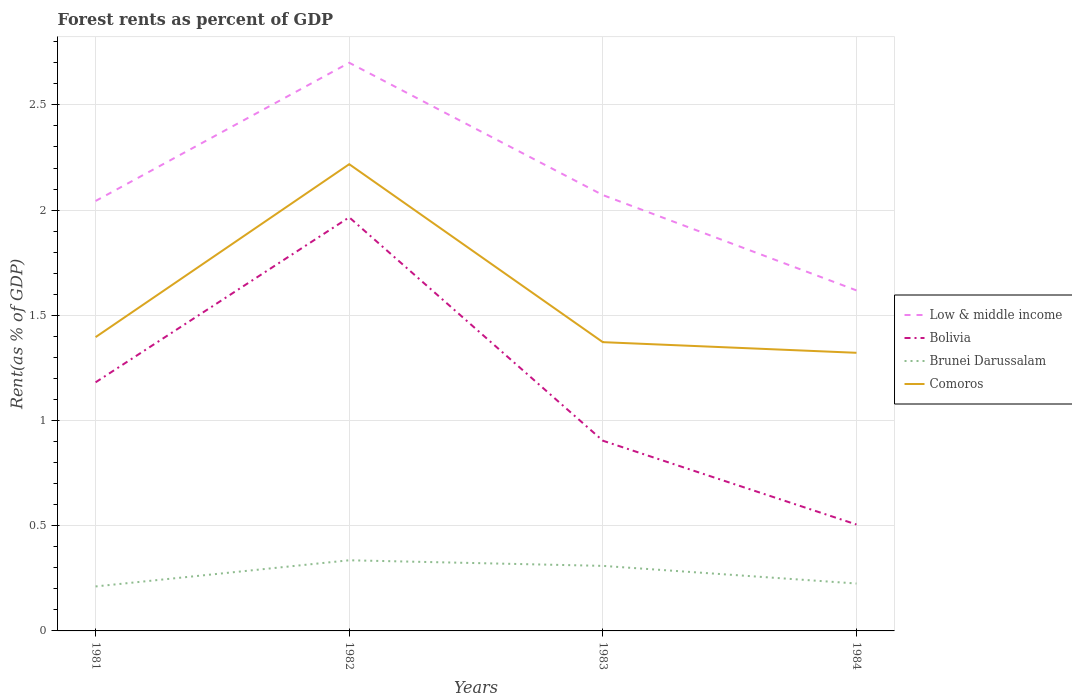Across all years, what is the maximum forest rent in Low & middle income?
Offer a very short reply. 1.62. What is the total forest rent in Low & middle income in the graph?
Make the answer very short. -0.66. What is the difference between the highest and the second highest forest rent in Bolivia?
Ensure brevity in your answer.  1.46. Is the forest rent in Bolivia strictly greater than the forest rent in Low & middle income over the years?
Give a very brief answer. Yes. Are the values on the major ticks of Y-axis written in scientific E-notation?
Offer a terse response. No. Where does the legend appear in the graph?
Keep it short and to the point. Center right. What is the title of the graph?
Offer a very short reply. Forest rents as percent of GDP. What is the label or title of the Y-axis?
Your answer should be very brief. Rent(as % of GDP). What is the Rent(as % of GDP) in Low & middle income in 1981?
Make the answer very short. 2.04. What is the Rent(as % of GDP) of Bolivia in 1981?
Your answer should be compact. 1.18. What is the Rent(as % of GDP) of Brunei Darussalam in 1981?
Your response must be concise. 0.21. What is the Rent(as % of GDP) of Comoros in 1981?
Keep it short and to the point. 1.4. What is the Rent(as % of GDP) of Low & middle income in 1982?
Ensure brevity in your answer.  2.7. What is the Rent(as % of GDP) of Bolivia in 1982?
Your answer should be very brief. 1.97. What is the Rent(as % of GDP) of Brunei Darussalam in 1982?
Give a very brief answer. 0.34. What is the Rent(as % of GDP) in Comoros in 1982?
Your answer should be compact. 2.22. What is the Rent(as % of GDP) of Low & middle income in 1983?
Your answer should be compact. 2.07. What is the Rent(as % of GDP) of Bolivia in 1983?
Provide a succinct answer. 0.9. What is the Rent(as % of GDP) in Brunei Darussalam in 1983?
Keep it short and to the point. 0.31. What is the Rent(as % of GDP) of Comoros in 1983?
Provide a short and direct response. 1.37. What is the Rent(as % of GDP) in Low & middle income in 1984?
Offer a terse response. 1.62. What is the Rent(as % of GDP) in Bolivia in 1984?
Your answer should be very brief. 0.51. What is the Rent(as % of GDP) of Brunei Darussalam in 1984?
Ensure brevity in your answer.  0.23. What is the Rent(as % of GDP) in Comoros in 1984?
Ensure brevity in your answer.  1.32. Across all years, what is the maximum Rent(as % of GDP) in Low & middle income?
Make the answer very short. 2.7. Across all years, what is the maximum Rent(as % of GDP) in Bolivia?
Your answer should be compact. 1.97. Across all years, what is the maximum Rent(as % of GDP) of Brunei Darussalam?
Make the answer very short. 0.34. Across all years, what is the maximum Rent(as % of GDP) of Comoros?
Offer a very short reply. 2.22. Across all years, what is the minimum Rent(as % of GDP) of Low & middle income?
Keep it short and to the point. 1.62. Across all years, what is the minimum Rent(as % of GDP) in Bolivia?
Provide a succinct answer. 0.51. Across all years, what is the minimum Rent(as % of GDP) of Brunei Darussalam?
Provide a short and direct response. 0.21. Across all years, what is the minimum Rent(as % of GDP) of Comoros?
Your answer should be compact. 1.32. What is the total Rent(as % of GDP) in Low & middle income in the graph?
Give a very brief answer. 8.43. What is the total Rent(as % of GDP) in Bolivia in the graph?
Your answer should be very brief. 4.56. What is the total Rent(as % of GDP) in Brunei Darussalam in the graph?
Ensure brevity in your answer.  1.08. What is the total Rent(as % of GDP) of Comoros in the graph?
Give a very brief answer. 6.31. What is the difference between the Rent(as % of GDP) in Low & middle income in 1981 and that in 1982?
Your answer should be very brief. -0.66. What is the difference between the Rent(as % of GDP) of Bolivia in 1981 and that in 1982?
Offer a terse response. -0.78. What is the difference between the Rent(as % of GDP) of Brunei Darussalam in 1981 and that in 1982?
Keep it short and to the point. -0.12. What is the difference between the Rent(as % of GDP) in Comoros in 1981 and that in 1982?
Keep it short and to the point. -0.82. What is the difference between the Rent(as % of GDP) in Low & middle income in 1981 and that in 1983?
Your answer should be very brief. -0.03. What is the difference between the Rent(as % of GDP) of Bolivia in 1981 and that in 1983?
Your answer should be compact. 0.28. What is the difference between the Rent(as % of GDP) in Brunei Darussalam in 1981 and that in 1983?
Provide a succinct answer. -0.1. What is the difference between the Rent(as % of GDP) in Comoros in 1981 and that in 1983?
Make the answer very short. 0.02. What is the difference between the Rent(as % of GDP) of Low & middle income in 1981 and that in 1984?
Offer a very short reply. 0.42. What is the difference between the Rent(as % of GDP) in Bolivia in 1981 and that in 1984?
Provide a succinct answer. 0.68. What is the difference between the Rent(as % of GDP) in Brunei Darussalam in 1981 and that in 1984?
Provide a short and direct response. -0.01. What is the difference between the Rent(as % of GDP) in Comoros in 1981 and that in 1984?
Your answer should be compact. 0.07. What is the difference between the Rent(as % of GDP) in Low & middle income in 1982 and that in 1983?
Ensure brevity in your answer.  0.63. What is the difference between the Rent(as % of GDP) in Bolivia in 1982 and that in 1983?
Provide a succinct answer. 1.06. What is the difference between the Rent(as % of GDP) in Brunei Darussalam in 1982 and that in 1983?
Your response must be concise. 0.03. What is the difference between the Rent(as % of GDP) of Comoros in 1982 and that in 1983?
Keep it short and to the point. 0.85. What is the difference between the Rent(as % of GDP) in Low & middle income in 1982 and that in 1984?
Your answer should be compact. 1.08. What is the difference between the Rent(as % of GDP) of Bolivia in 1982 and that in 1984?
Your response must be concise. 1.46. What is the difference between the Rent(as % of GDP) in Brunei Darussalam in 1982 and that in 1984?
Provide a short and direct response. 0.11. What is the difference between the Rent(as % of GDP) of Comoros in 1982 and that in 1984?
Offer a terse response. 0.9. What is the difference between the Rent(as % of GDP) of Low & middle income in 1983 and that in 1984?
Your answer should be very brief. 0.45. What is the difference between the Rent(as % of GDP) in Bolivia in 1983 and that in 1984?
Offer a very short reply. 0.4. What is the difference between the Rent(as % of GDP) of Brunei Darussalam in 1983 and that in 1984?
Your answer should be compact. 0.08. What is the difference between the Rent(as % of GDP) of Comoros in 1983 and that in 1984?
Provide a short and direct response. 0.05. What is the difference between the Rent(as % of GDP) in Low & middle income in 1981 and the Rent(as % of GDP) in Bolivia in 1982?
Keep it short and to the point. 0.08. What is the difference between the Rent(as % of GDP) in Low & middle income in 1981 and the Rent(as % of GDP) in Brunei Darussalam in 1982?
Give a very brief answer. 1.71. What is the difference between the Rent(as % of GDP) of Low & middle income in 1981 and the Rent(as % of GDP) of Comoros in 1982?
Offer a terse response. -0.17. What is the difference between the Rent(as % of GDP) of Bolivia in 1981 and the Rent(as % of GDP) of Brunei Darussalam in 1982?
Give a very brief answer. 0.85. What is the difference between the Rent(as % of GDP) in Bolivia in 1981 and the Rent(as % of GDP) in Comoros in 1982?
Your response must be concise. -1.04. What is the difference between the Rent(as % of GDP) in Brunei Darussalam in 1981 and the Rent(as % of GDP) in Comoros in 1982?
Provide a succinct answer. -2.01. What is the difference between the Rent(as % of GDP) in Low & middle income in 1981 and the Rent(as % of GDP) in Bolivia in 1983?
Ensure brevity in your answer.  1.14. What is the difference between the Rent(as % of GDP) in Low & middle income in 1981 and the Rent(as % of GDP) in Brunei Darussalam in 1983?
Give a very brief answer. 1.73. What is the difference between the Rent(as % of GDP) in Low & middle income in 1981 and the Rent(as % of GDP) in Comoros in 1983?
Ensure brevity in your answer.  0.67. What is the difference between the Rent(as % of GDP) in Bolivia in 1981 and the Rent(as % of GDP) in Brunei Darussalam in 1983?
Provide a short and direct response. 0.87. What is the difference between the Rent(as % of GDP) in Bolivia in 1981 and the Rent(as % of GDP) in Comoros in 1983?
Make the answer very short. -0.19. What is the difference between the Rent(as % of GDP) of Brunei Darussalam in 1981 and the Rent(as % of GDP) of Comoros in 1983?
Ensure brevity in your answer.  -1.16. What is the difference between the Rent(as % of GDP) of Low & middle income in 1981 and the Rent(as % of GDP) of Bolivia in 1984?
Offer a terse response. 1.54. What is the difference between the Rent(as % of GDP) in Low & middle income in 1981 and the Rent(as % of GDP) in Brunei Darussalam in 1984?
Offer a very short reply. 1.82. What is the difference between the Rent(as % of GDP) in Low & middle income in 1981 and the Rent(as % of GDP) in Comoros in 1984?
Offer a very short reply. 0.72. What is the difference between the Rent(as % of GDP) of Bolivia in 1981 and the Rent(as % of GDP) of Brunei Darussalam in 1984?
Your answer should be compact. 0.96. What is the difference between the Rent(as % of GDP) in Bolivia in 1981 and the Rent(as % of GDP) in Comoros in 1984?
Make the answer very short. -0.14. What is the difference between the Rent(as % of GDP) in Brunei Darussalam in 1981 and the Rent(as % of GDP) in Comoros in 1984?
Your response must be concise. -1.11. What is the difference between the Rent(as % of GDP) of Low & middle income in 1982 and the Rent(as % of GDP) of Bolivia in 1983?
Keep it short and to the point. 1.8. What is the difference between the Rent(as % of GDP) in Low & middle income in 1982 and the Rent(as % of GDP) in Brunei Darussalam in 1983?
Offer a very short reply. 2.39. What is the difference between the Rent(as % of GDP) of Low & middle income in 1982 and the Rent(as % of GDP) of Comoros in 1983?
Your response must be concise. 1.33. What is the difference between the Rent(as % of GDP) of Bolivia in 1982 and the Rent(as % of GDP) of Brunei Darussalam in 1983?
Keep it short and to the point. 1.66. What is the difference between the Rent(as % of GDP) in Bolivia in 1982 and the Rent(as % of GDP) in Comoros in 1983?
Provide a short and direct response. 0.59. What is the difference between the Rent(as % of GDP) of Brunei Darussalam in 1982 and the Rent(as % of GDP) of Comoros in 1983?
Give a very brief answer. -1.04. What is the difference between the Rent(as % of GDP) in Low & middle income in 1982 and the Rent(as % of GDP) in Bolivia in 1984?
Your answer should be compact. 2.19. What is the difference between the Rent(as % of GDP) of Low & middle income in 1982 and the Rent(as % of GDP) of Brunei Darussalam in 1984?
Offer a terse response. 2.48. What is the difference between the Rent(as % of GDP) in Low & middle income in 1982 and the Rent(as % of GDP) in Comoros in 1984?
Provide a short and direct response. 1.38. What is the difference between the Rent(as % of GDP) of Bolivia in 1982 and the Rent(as % of GDP) of Brunei Darussalam in 1984?
Your answer should be compact. 1.74. What is the difference between the Rent(as % of GDP) in Bolivia in 1982 and the Rent(as % of GDP) in Comoros in 1984?
Provide a short and direct response. 0.64. What is the difference between the Rent(as % of GDP) in Brunei Darussalam in 1982 and the Rent(as % of GDP) in Comoros in 1984?
Provide a short and direct response. -0.99. What is the difference between the Rent(as % of GDP) in Low & middle income in 1983 and the Rent(as % of GDP) in Bolivia in 1984?
Your answer should be compact. 1.57. What is the difference between the Rent(as % of GDP) of Low & middle income in 1983 and the Rent(as % of GDP) of Brunei Darussalam in 1984?
Provide a succinct answer. 1.85. What is the difference between the Rent(as % of GDP) of Low & middle income in 1983 and the Rent(as % of GDP) of Comoros in 1984?
Give a very brief answer. 0.75. What is the difference between the Rent(as % of GDP) of Bolivia in 1983 and the Rent(as % of GDP) of Brunei Darussalam in 1984?
Ensure brevity in your answer.  0.68. What is the difference between the Rent(as % of GDP) of Bolivia in 1983 and the Rent(as % of GDP) of Comoros in 1984?
Ensure brevity in your answer.  -0.42. What is the difference between the Rent(as % of GDP) in Brunei Darussalam in 1983 and the Rent(as % of GDP) in Comoros in 1984?
Keep it short and to the point. -1.01. What is the average Rent(as % of GDP) in Low & middle income per year?
Your answer should be compact. 2.11. What is the average Rent(as % of GDP) in Bolivia per year?
Your answer should be compact. 1.14. What is the average Rent(as % of GDP) in Brunei Darussalam per year?
Make the answer very short. 0.27. What is the average Rent(as % of GDP) in Comoros per year?
Provide a succinct answer. 1.58. In the year 1981, what is the difference between the Rent(as % of GDP) in Low & middle income and Rent(as % of GDP) in Bolivia?
Your response must be concise. 0.86. In the year 1981, what is the difference between the Rent(as % of GDP) in Low & middle income and Rent(as % of GDP) in Brunei Darussalam?
Keep it short and to the point. 1.83. In the year 1981, what is the difference between the Rent(as % of GDP) of Low & middle income and Rent(as % of GDP) of Comoros?
Keep it short and to the point. 0.65. In the year 1981, what is the difference between the Rent(as % of GDP) in Bolivia and Rent(as % of GDP) in Brunei Darussalam?
Your answer should be compact. 0.97. In the year 1981, what is the difference between the Rent(as % of GDP) in Bolivia and Rent(as % of GDP) in Comoros?
Make the answer very short. -0.21. In the year 1981, what is the difference between the Rent(as % of GDP) in Brunei Darussalam and Rent(as % of GDP) in Comoros?
Give a very brief answer. -1.18. In the year 1982, what is the difference between the Rent(as % of GDP) of Low & middle income and Rent(as % of GDP) of Bolivia?
Offer a terse response. 0.73. In the year 1982, what is the difference between the Rent(as % of GDP) of Low & middle income and Rent(as % of GDP) of Brunei Darussalam?
Provide a succinct answer. 2.36. In the year 1982, what is the difference between the Rent(as % of GDP) of Low & middle income and Rent(as % of GDP) of Comoros?
Ensure brevity in your answer.  0.48. In the year 1982, what is the difference between the Rent(as % of GDP) of Bolivia and Rent(as % of GDP) of Brunei Darussalam?
Your answer should be compact. 1.63. In the year 1982, what is the difference between the Rent(as % of GDP) in Bolivia and Rent(as % of GDP) in Comoros?
Keep it short and to the point. -0.25. In the year 1982, what is the difference between the Rent(as % of GDP) in Brunei Darussalam and Rent(as % of GDP) in Comoros?
Offer a very short reply. -1.88. In the year 1983, what is the difference between the Rent(as % of GDP) of Low & middle income and Rent(as % of GDP) of Bolivia?
Your answer should be very brief. 1.17. In the year 1983, what is the difference between the Rent(as % of GDP) of Low & middle income and Rent(as % of GDP) of Brunei Darussalam?
Keep it short and to the point. 1.76. In the year 1983, what is the difference between the Rent(as % of GDP) of Low & middle income and Rent(as % of GDP) of Comoros?
Your response must be concise. 0.7. In the year 1983, what is the difference between the Rent(as % of GDP) in Bolivia and Rent(as % of GDP) in Brunei Darussalam?
Your answer should be very brief. 0.59. In the year 1983, what is the difference between the Rent(as % of GDP) in Bolivia and Rent(as % of GDP) in Comoros?
Your answer should be very brief. -0.47. In the year 1983, what is the difference between the Rent(as % of GDP) of Brunei Darussalam and Rent(as % of GDP) of Comoros?
Ensure brevity in your answer.  -1.06. In the year 1984, what is the difference between the Rent(as % of GDP) in Low & middle income and Rent(as % of GDP) in Bolivia?
Make the answer very short. 1.11. In the year 1984, what is the difference between the Rent(as % of GDP) in Low & middle income and Rent(as % of GDP) in Brunei Darussalam?
Provide a succinct answer. 1.39. In the year 1984, what is the difference between the Rent(as % of GDP) of Low & middle income and Rent(as % of GDP) of Comoros?
Ensure brevity in your answer.  0.3. In the year 1984, what is the difference between the Rent(as % of GDP) in Bolivia and Rent(as % of GDP) in Brunei Darussalam?
Keep it short and to the point. 0.28. In the year 1984, what is the difference between the Rent(as % of GDP) in Bolivia and Rent(as % of GDP) in Comoros?
Make the answer very short. -0.82. In the year 1984, what is the difference between the Rent(as % of GDP) of Brunei Darussalam and Rent(as % of GDP) of Comoros?
Make the answer very short. -1.1. What is the ratio of the Rent(as % of GDP) in Low & middle income in 1981 to that in 1982?
Offer a terse response. 0.76. What is the ratio of the Rent(as % of GDP) in Bolivia in 1981 to that in 1982?
Provide a short and direct response. 0.6. What is the ratio of the Rent(as % of GDP) of Brunei Darussalam in 1981 to that in 1982?
Give a very brief answer. 0.63. What is the ratio of the Rent(as % of GDP) in Comoros in 1981 to that in 1982?
Your answer should be compact. 0.63. What is the ratio of the Rent(as % of GDP) in Low & middle income in 1981 to that in 1983?
Make the answer very short. 0.99. What is the ratio of the Rent(as % of GDP) of Bolivia in 1981 to that in 1983?
Offer a terse response. 1.31. What is the ratio of the Rent(as % of GDP) of Brunei Darussalam in 1981 to that in 1983?
Provide a succinct answer. 0.68. What is the ratio of the Rent(as % of GDP) in Comoros in 1981 to that in 1983?
Your answer should be very brief. 1.02. What is the ratio of the Rent(as % of GDP) of Low & middle income in 1981 to that in 1984?
Provide a succinct answer. 1.26. What is the ratio of the Rent(as % of GDP) of Bolivia in 1981 to that in 1984?
Make the answer very short. 2.34. What is the ratio of the Rent(as % of GDP) in Brunei Darussalam in 1981 to that in 1984?
Ensure brevity in your answer.  0.94. What is the ratio of the Rent(as % of GDP) in Comoros in 1981 to that in 1984?
Your answer should be very brief. 1.06. What is the ratio of the Rent(as % of GDP) of Low & middle income in 1982 to that in 1983?
Provide a short and direct response. 1.3. What is the ratio of the Rent(as % of GDP) of Bolivia in 1982 to that in 1983?
Give a very brief answer. 2.17. What is the ratio of the Rent(as % of GDP) in Brunei Darussalam in 1982 to that in 1983?
Make the answer very short. 1.09. What is the ratio of the Rent(as % of GDP) in Comoros in 1982 to that in 1983?
Give a very brief answer. 1.62. What is the ratio of the Rent(as % of GDP) of Low & middle income in 1982 to that in 1984?
Your answer should be very brief. 1.67. What is the ratio of the Rent(as % of GDP) in Bolivia in 1982 to that in 1984?
Provide a short and direct response. 3.89. What is the ratio of the Rent(as % of GDP) in Brunei Darussalam in 1982 to that in 1984?
Make the answer very short. 1.49. What is the ratio of the Rent(as % of GDP) in Comoros in 1982 to that in 1984?
Offer a terse response. 1.68. What is the ratio of the Rent(as % of GDP) of Low & middle income in 1983 to that in 1984?
Keep it short and to the point. 1.28. What is the ratio of the Rent(as % of GDP) of Bolivia in 1983 to that in 1984?
Provide a short and direct response. 1.79. What is the ratio of the Rent(as % of GDP) of Brunei Darussalam in 1983 to that in 1984?
Offer a very short reply. 1.37. What is the ratio of the Rent(as % of GDP) in Comoros in 1983 to that in 1984?
Ensure brevity in your answer.  1.04. What is the difference between the highest and the second highest Rent(as % of GDP) in Low & middle income?
Your response must be concise. 0.63. What is the difference between the highest and the second highest Rent(as % of GDP) in Bolivia?
Your answer should be very brief. 0.78. What is the difference between the highest and the second highest Rent(as % of GDP) in Brunei Darussalam?
Provide a short and direct response. 0.03. What is the difference between the highest and the second highest Rent(as % of GDP) of Comoros?
Your answer should be compact. 0.82. What is the difference between the highest and the lowest Rent(as % of GDP) in Low & middle income?
Make the answer very short. 1.08. What is the difference between the highest and the lowest Rent(as % of GDP) in Bolivia?
Keep it short and to the point. 1.46. What is the difference between the highest and the lowest Rent(as % of GDP) in Brunei Darussalam?
Offer a very short reply. 0.12. What is the difference between the highest and the lowest Rent(as % of GDP) in Comoros?
Provide a succinct answer. 0.9. 